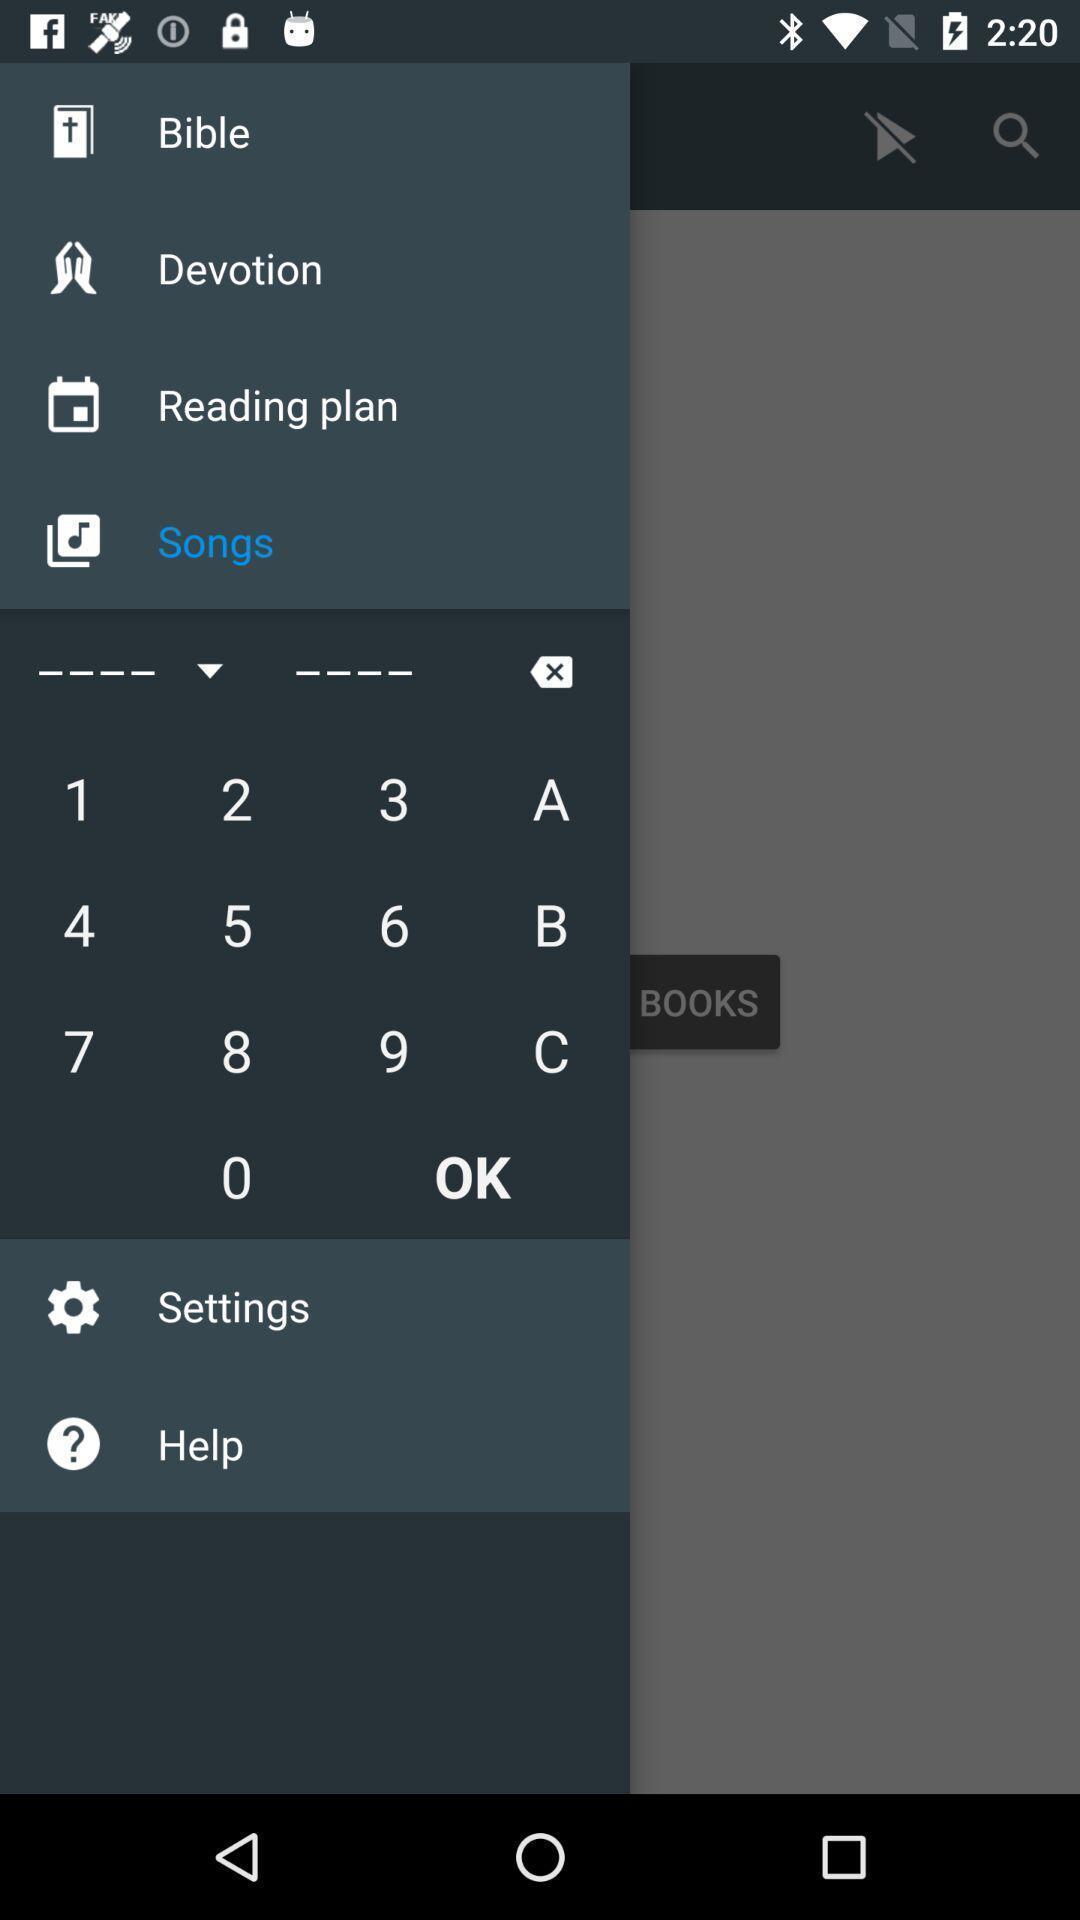Explain the elements present in this screenshot. Screen shows different options. 